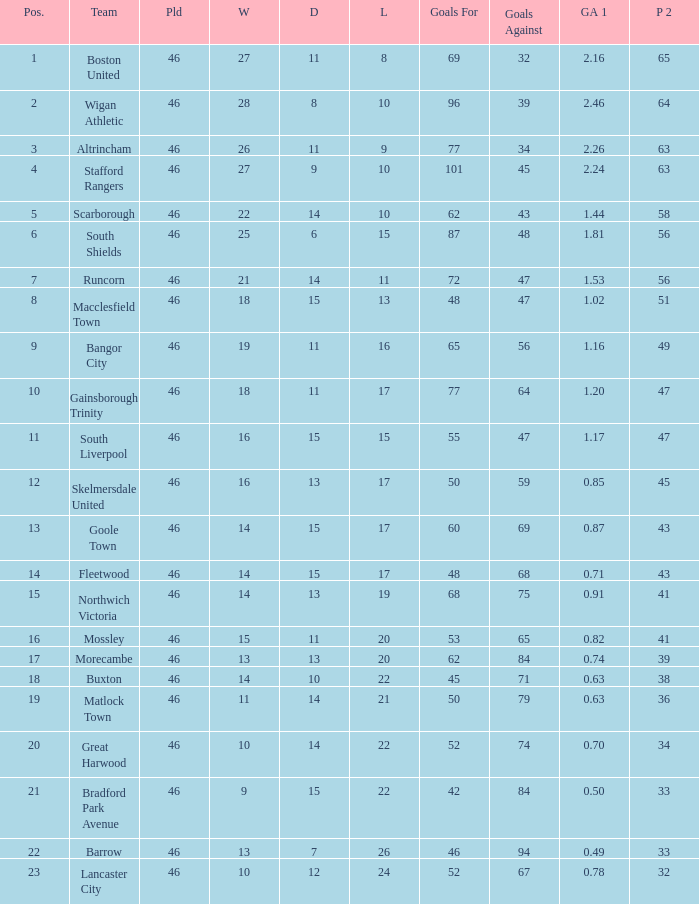How many points did Goole Town accumulate? 1.0. 